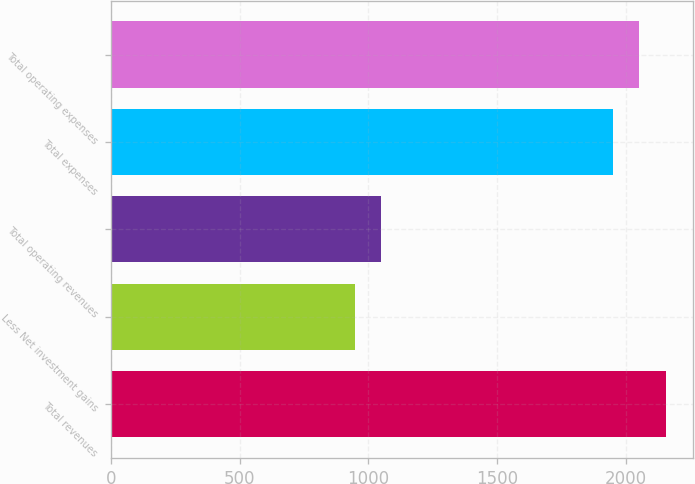Convert chart to OTSL. <chart><loc_0><loc_0><loc_500><loc_500><bar_chart><fcel>Total revenues<fcel>Less Net investment gains<fcel>Total operating revenues<fcel>Total expenses<fcel>Total operating expenses<nl><fcel>2155.4<fcel>947<fcel>1050.2<fcel>1949<fcel>2052.2<nl></chart> 